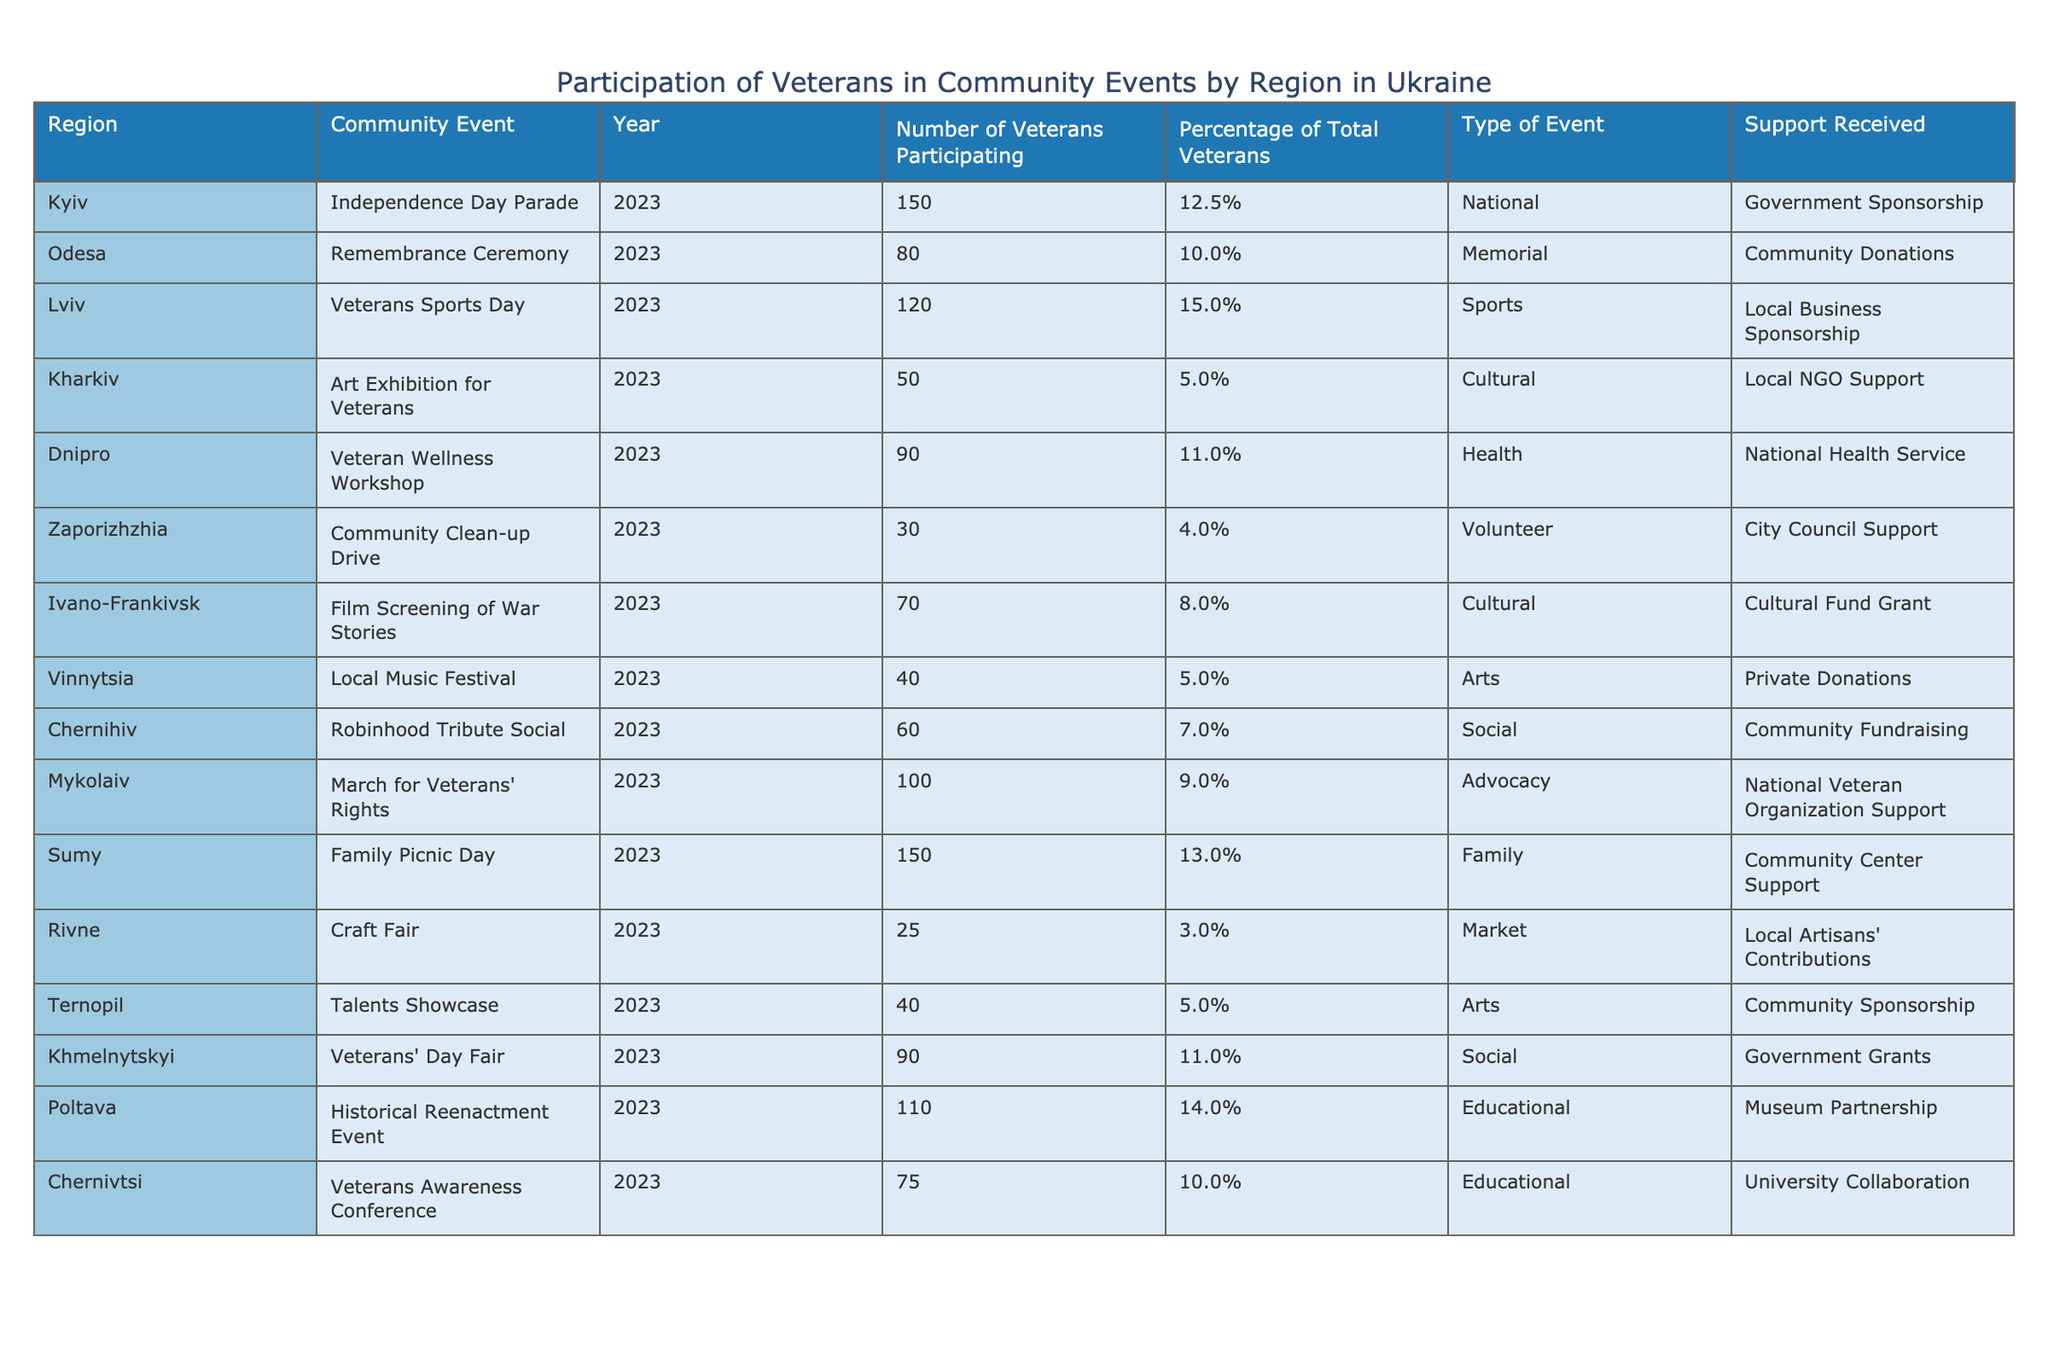What is the highest number of veterans participating in a community event? The table shows that the highest number of veterans participating is 150, which is for both the Independence Day Parade in Kyiv and the Family Picnic Day in Sumy.
Answer: 150 In which region did the fewest veterans participate in community events? The table indicates that Rivne had the fewest veterans participating, with only 25 veterans involved in the Craft Fair.
Answer: Rivne What percentage of total veterans participated in the Veterans Sports Day in Lviv? The table lists the percentage of total veterans participating in the Veterans Sports Day in Lviv as 15.0%.
Answer: 15.0% How many more veterans participated in the March for Veterans' Rights than in the Craft Fair? The number of veterans in the March for Veterans' Rights is 100, and in the Craft Fair, it's 25. Therefore, 100 - 25 = 75 more veterans participated in the March.
Answer: 75 Is the support for the Remembrance Ceremony in Odesa provided by a government agency? The support for the Remembrance Ceremony is from Community Donations, not a government agency.
Answer: No What is the average number of veterans participating across all events listed in the table? To find the average, we add up all veterans participating (150 + 80 + 120 + 50 + 90 + 30 + 70 + 40 + 60 + 100 + 150 + 25 + 40 + 90 + 110 + 75) = 1,250, and there are 16 events. The average is 1,250 / 16 = 78.125, which can be rounded to 78.
Answer: 78 Which type of event had the highest participation based on the number of veterans? Looking at the types of events, the Family Picnic Day and Independence Day Parade had the highest participation with 150 veterans each.
Answer: Family Picnic Day and Independence Day Parade How many regions had more than 100 veterans participating? From the table, the regions with more than 100 veterans are Kyiv, Sumy, and Poltava (150, 150, and 110 respectively), totaling 3 regions with more than 100 participants.
Answer: 3 What is the total number of veterans participating in social events listed? The social events listed are the Robinhood Tribute Social, Veterans' Day Fair, and March for Veterans' Rights with 60, 90, and 100 veterans respectively. The total is 60 + 90 + 100 = 250.
Answer: 250 Which community event had the least support in terms of funding or resources? The Community Clean-up Drive in Zaporizhzhia received support from City Council Support, which is one of the less formal sources compared to government sponsorships or grants.
Answer: Community Clean-up Drive 